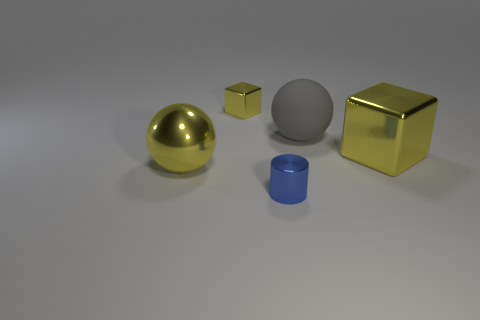Do the blue metallic cylinder and the matte sphere have the same size? Based on the image, the blue metallic cylinder and the matte sphere do not have the same size. The sphere appears to be larger in comparison to the cylinder. 